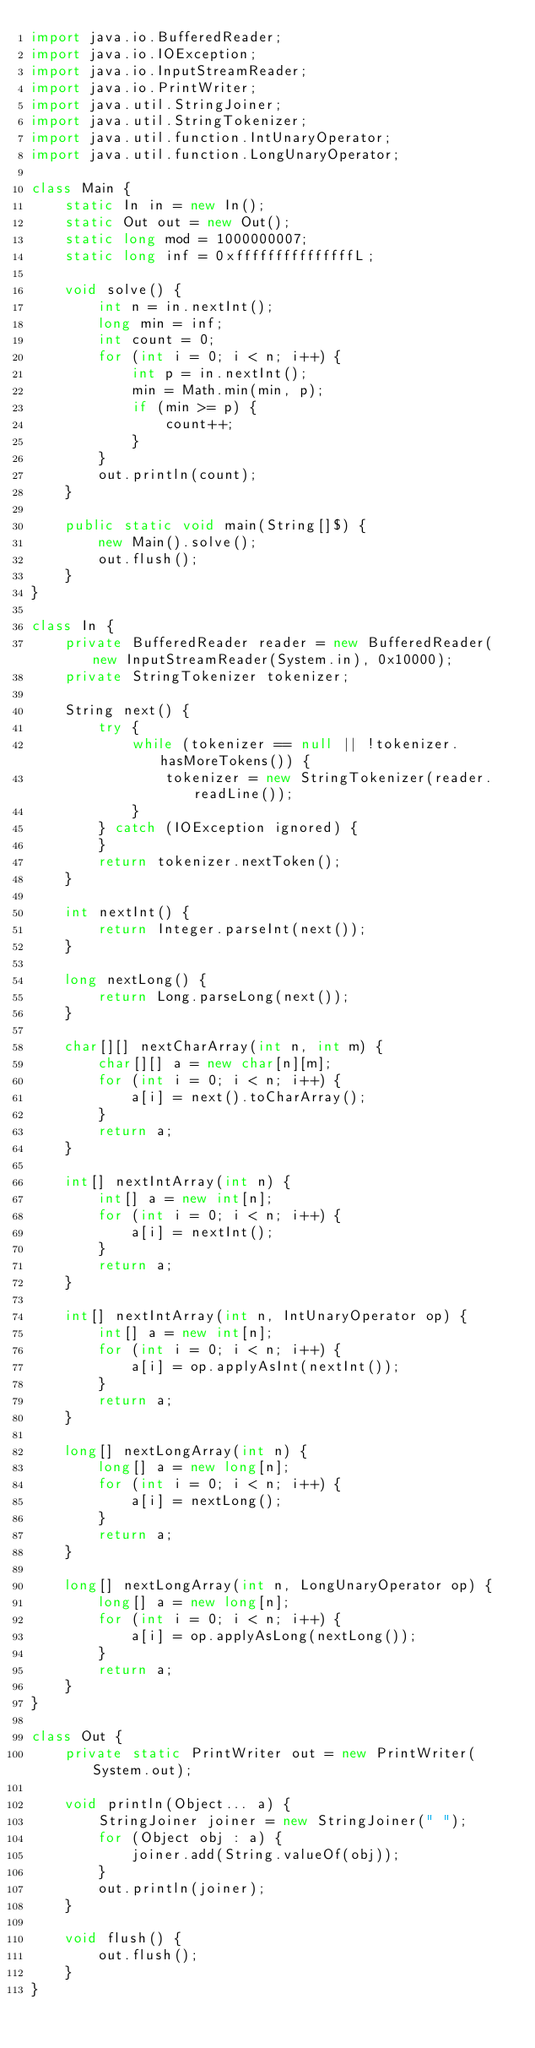<code> <loc_0><loc_0><loc_500><loc_500><_Java_>import java.io.BufferedReader;
import java.io.IOException;
import java.io.InputStreamReader;
import java.io.PrintWriter;
import java.util.StringJoiner;
import java.util.StringTokenizer;
import java.util.function.IntUnaryOperator;
import java.util.function.LongUnaryOperator;

class Main {
    static In in = new In();
    static Out out = new Out();
    static long mod = 1000000007;
    static long inf = 0xfffffffffffffffL;

    void solve() {
        int n = in.nextInt();
        long min = inf;
        int count = 0;
        for (int i = 0; i < n; i++) {
            int p = in.nextInt();
            min = Math.min(min, p);
            if (min >= p) {
                count++;
            }
        }
        out.println(count);
    }

    public static void main(String[]$) {
        new Main().solve();
        out.flush();
    }
}

class In {
    private BufferedReader reader = new BufferedReader(new InputStreamReader(System.in), 0x10000);
    private StringTokenizer tokenizer;

    String next() {
        try {
            while (tokenizer == null || !tokenizer.hasMoreTokens()) {
                tokenizer = new StringTokenizer(reader.readLine());
            }
        } catch (IOException ignored) {
        }
        return tokenizer.nextToken();
    }

    int nextInt() {
        return Integer.parseInt(next());
    }

    long nextLong() {
        return Long.parseLong(next());
    }

    char[][] nextCharArray(int n, int m) {
        char[][] a = new char[n][m];
        for (int i = 0; i < n; i++) {
            a[i] = next().toCharArray();
        }
        return a;
    }

    int[] nextIntArray(int n) {
        int[] a = new int[n];
        for (int i = 0; i < n; i++) {
            a[i] = nextInt();
        }
        return a;
    }

    int[] nextIntArray(int n, IntUnaryOperator op) {
        int[] a = new int[n];
        for (int i = 0; i < n; i++) {
            a[i] = op.applyAsInt(nextInt());
        }
        return a;
    }

    long[] nextLongArray(int n) {
        long[] a = new long[n];
        for (int i = 0; i < n; i++) {
            a[i] = nextLong();
        }
        return a;
    }

    long[] nextLongArray(int n, LongUnaryOperator op) {
        long[] a = new long[n];
        for (int i = 0; i < n; i++) {
            a[i] = op.applyAsLong(nextLong());
        }
        return a;
    }
}

class Out {
    private static PrintWriter out = new PrintWriter(System.out);

    void println(Object... a) {
        StringJoiner joiner = new StringJoiner(" ");
        for (Object obj : a) {
            joiner.add(String.valueOf(obj));
        }
        out.println(joiner);
    }

    void flush() {
        out.flush();
    }
}
</code> 